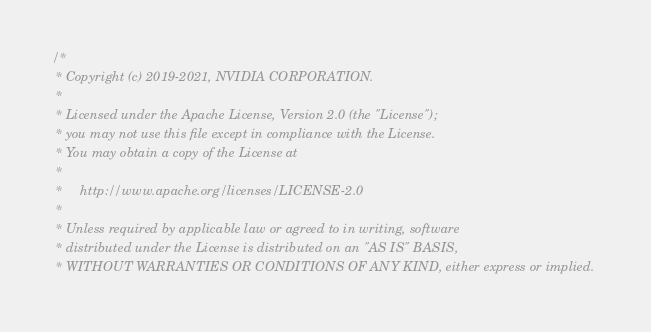Convert code to text. <code><loc_0><loc_0><loc_500><loc_500><_Cuda_>/*
 * Copyright (c) 2019-2021, NVIDIA CORPORATION.
 *
 * Licensed under the Apache License, Version 2.0 (the "License");
 * you may not use this file except in compliance with the License.
 * You may obtain a copy of the License at
 *
 *     http://www.apache.org/licenses/LICENSE-2.0
 *
 * Unless required by applicable law or agreed to in writing, software
 * distributed under the License is distributed on an "AS IS" BASIS,
 * WITHOUT WARRANTIES OR CONDITIONS OF ANY KIND, either express or implied.</code> 